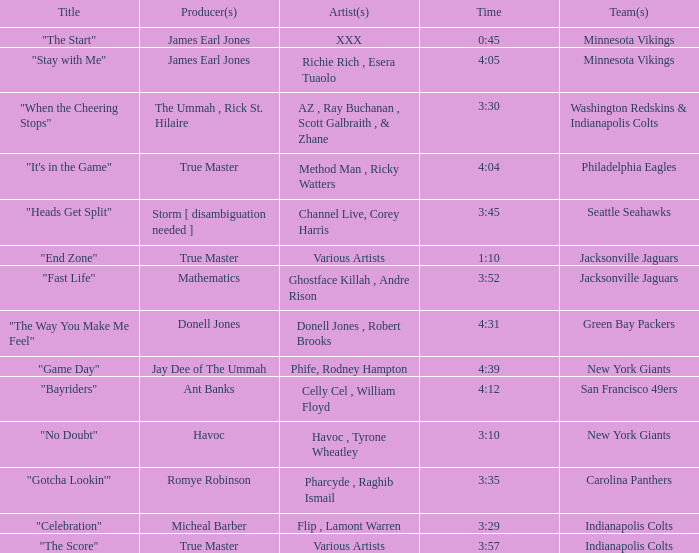Who is the creator of the seattle seahawks track? Channel Live, Corey Harris. 